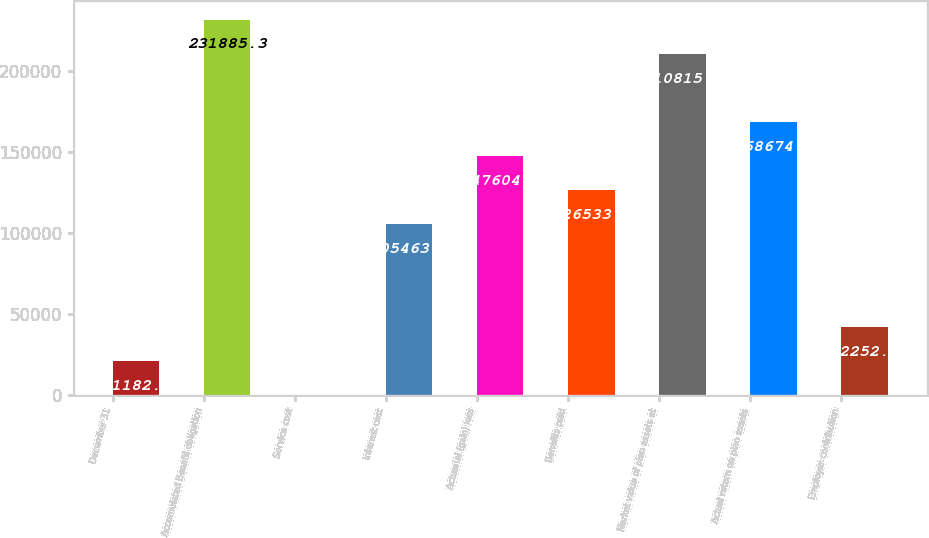Convert chart. <chart><loc_0><loc_0><loc_500><loc_500><bar_chart><fcel>December 31<fcel>Accumulated Benefit obligation<fcel>Service cost<fcel>Interest cost<fcel>Actuarial (gain) loss<fcel>Benefits paid<fcel>Market value of plan assets at<fcel>Actual return on plan assets<fcel>Employer contribution<nl><fcel>21182.3<fcel>231885<fcel>112<fcel>105464<fcel>147604<fcel>126534<fcel>210815<fcel>168674<fcel>42252.6<nl></chart> 